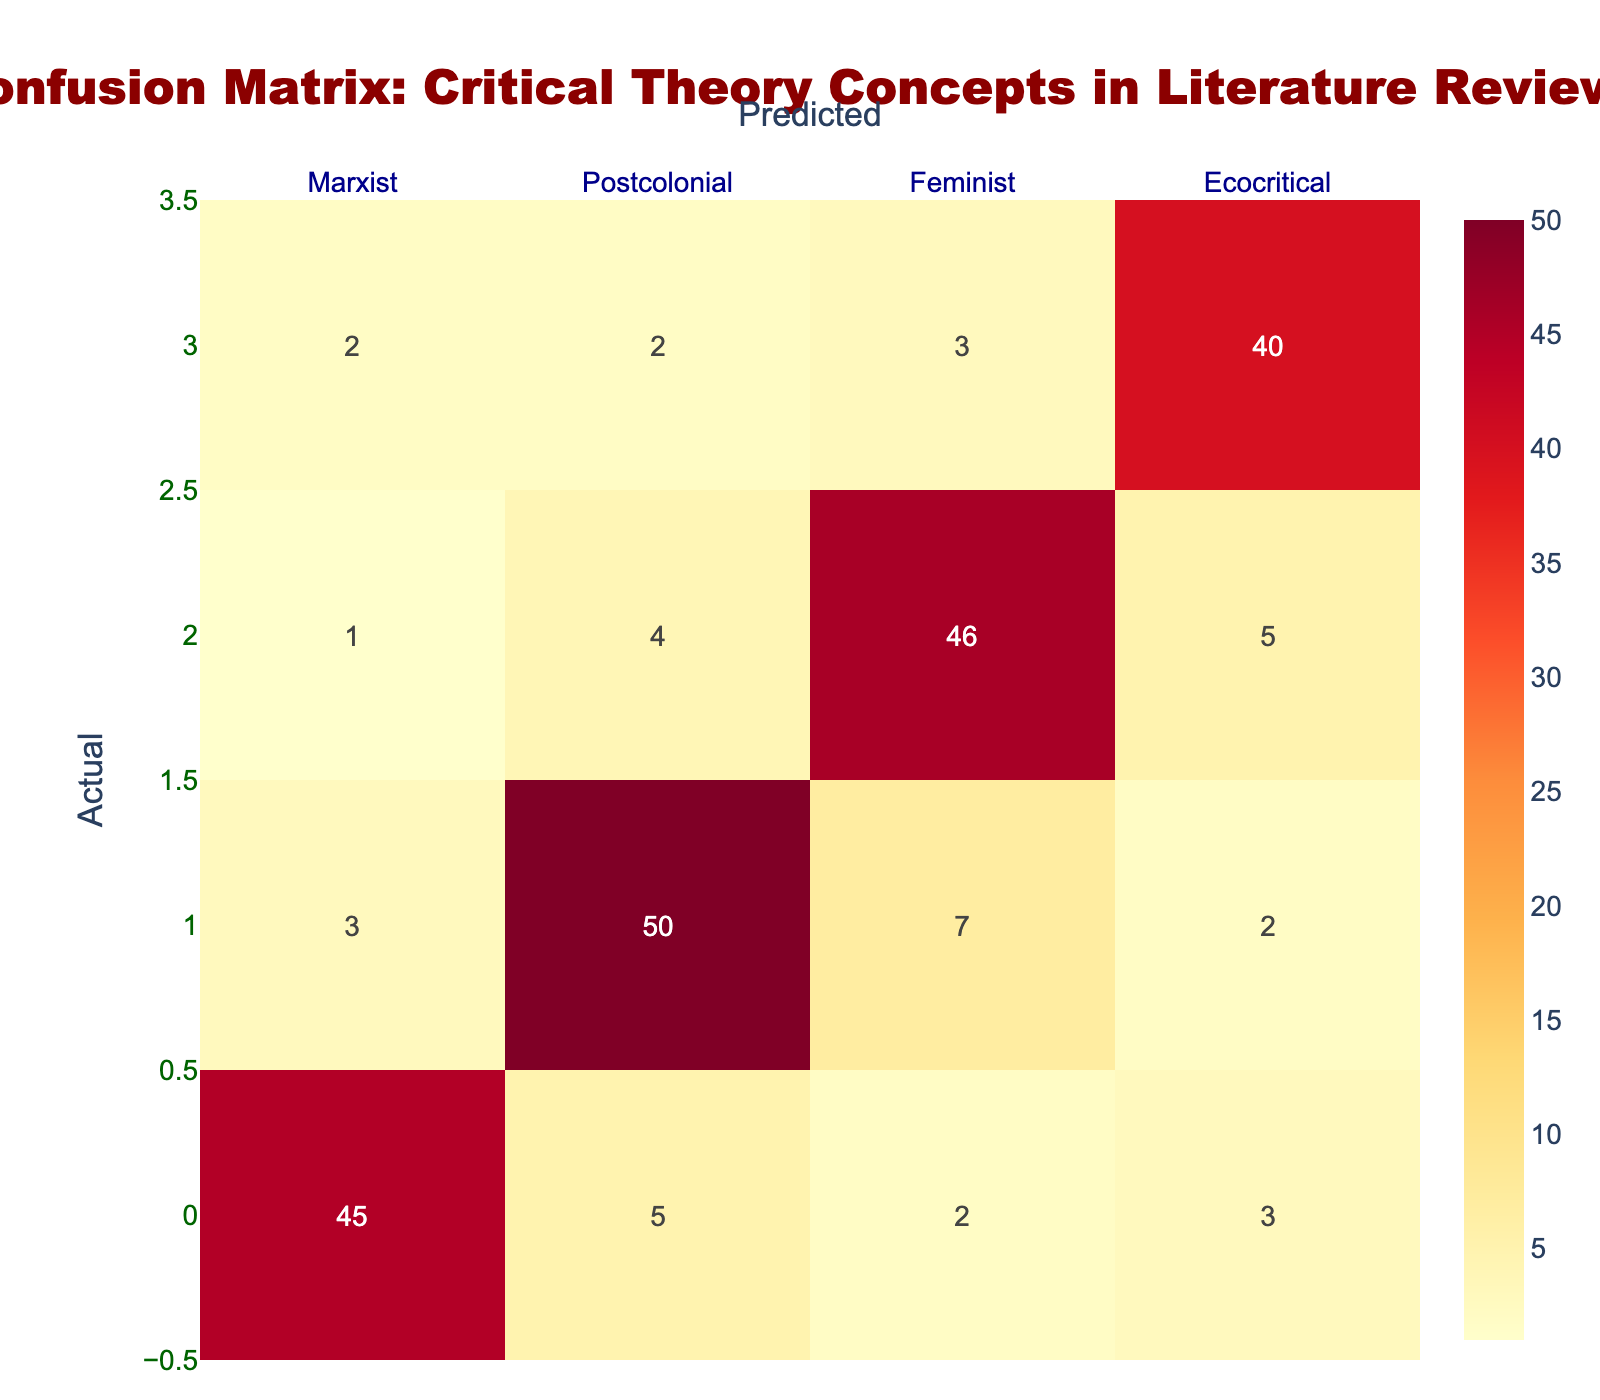What is the number of documents that were incorrectly classified as Marxist? To find this, we look at the Marxist column excluding the true positive (the value in the intersection of Actual and Predicted is 45). The incorrect classifications are those predicted as Postcolonial (5), Feminist (2), and Ecocritical (3). Adding them together gives 5 + 2 + 3 = 10.
Answer: 10 What is the total number of documents that were predicted as Feminist? We find the total of the Feminist column in the prediction row: Marxist (1), Postcolonial (4), Feminist (46), and Ecocritical (3). Adding these gives 1 + 4 + 46 + 3 = 54.
Answer: 54 Is it true that more documents were classified as Postcolonial than as Ecocritical? We compare the total values for Postcolonial and Ecocritical. The number of documents predicted as Postcolonial is 50, and for Ecocritical is 40. Since 50 is greater than 40, the statement is true.
Answer: Yes What is the average number of documents actually categorized as Feminist across the predicted categories? Looking at the Feminist row, we see actual counts are 1, 4, 46, and 5. To find the average, we sum these values (1 + 4 + 46 + 5 = 56) and divide by the number of categories (4). Therefore, the average is 56 / 4 = 14.
Answer: 14 What is the total number of documents that were predicted incorrectly across all categories? We sum the off-diagonal elements of the confusion matrix: Looking under Marxist (5 + 2 + 3), Postcolonial (3 + 7 + 2), Feminist (1 + 4 + 5), and Ecocritical (2 + 2 + 3). This totals to (10 + 12 + 10 + 7) = 39.
Answer: 39 How many more documents were correctly classified as Postcolonial compared to those correctly classified as Ecocritical? We check the true positive values for Postcolonial (50) and Ecocritical (40). The difference is 50 - 40 = 10.
Answer: 10 Which category had the highest number of correct classifications? The correct classes can be found on the diagonal of the confusion matrix: 45 (Marxist), 50 (Postcolonial), 46 (Feminist), and 40 (Ecocritical). The highest value is 50, for Postcolonial.
Answer: Postcolonial What percentage of the total documents were categorized as Feminist? To calculate this, sum the entire confusion matrix, which totals to 45 + 5 + 2 + 3 + 3 + 50 + 7 + 2 + 1 + 4 + 46 + 5 + 2 + 2 + 3 + 40 = 220. The total documents correctly classified as Feminist is 46. Thus, the percentage is (46 / 220) * 100, approximately 20.91%.
Answer: 20.91% How many documents were predicted as Ecocritical that were not truly Ecocritical? Referring to the Ecocritical row, we see that 2 were predicted as Marxist, 2 as Postcolonial, and 3 as Feminist. Summing these values (2 + 2 + 3 = 7) gives us the total of documents incorrectly categorized.
Answer: 7 